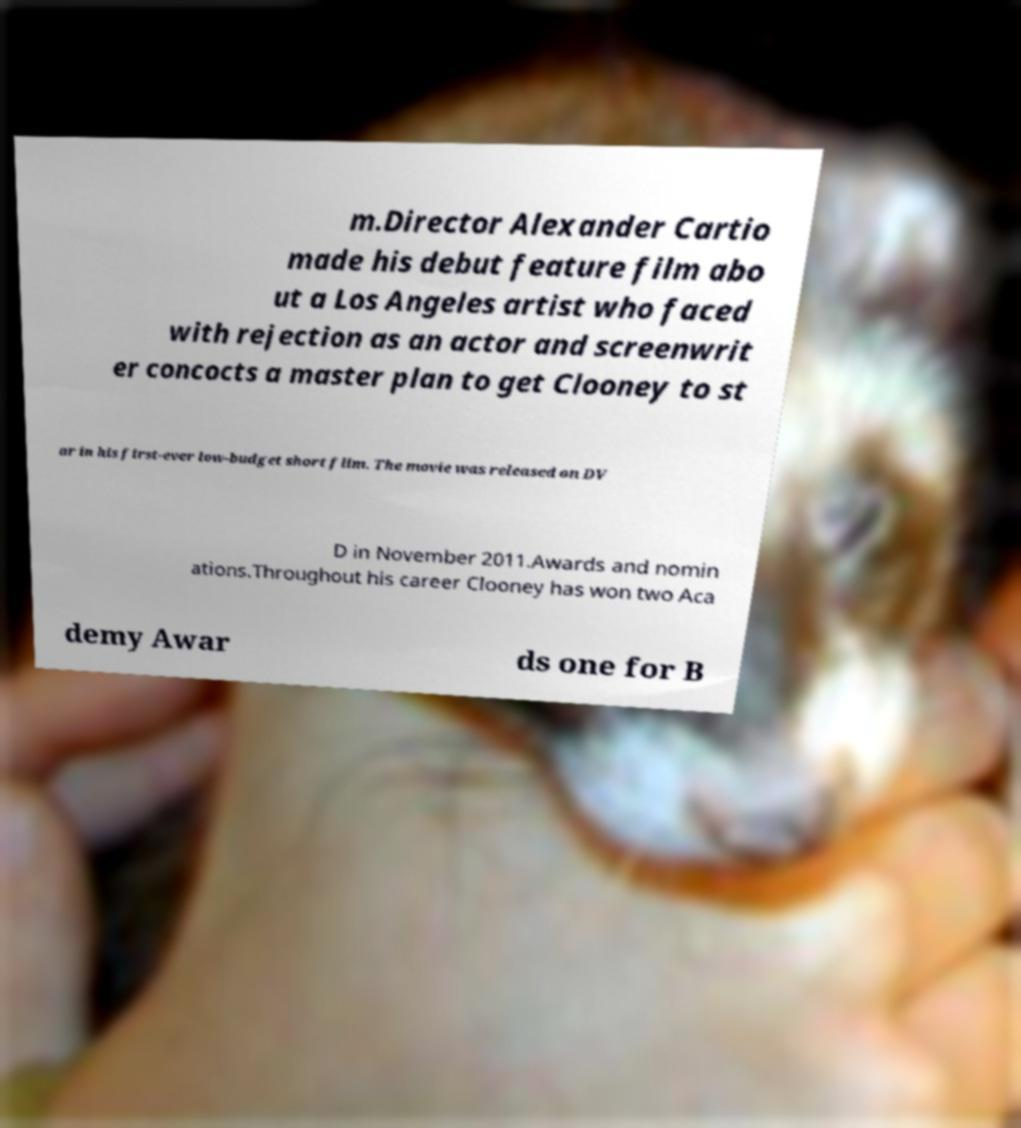Please read and relay the text visible in this image. What does it say? m.Director Alexander Cartio made his debut feature film abo ut a Los Angeles artist who faced with rejection as an actor and screenwrit er concocts a master plan to get Clooney to st ar in his first-ever low-budget short film. The movie was released on DV D in November 2011.Awards and nomin ations.Throughout his career Clooney has won two Aca demy Awar ds one for B 